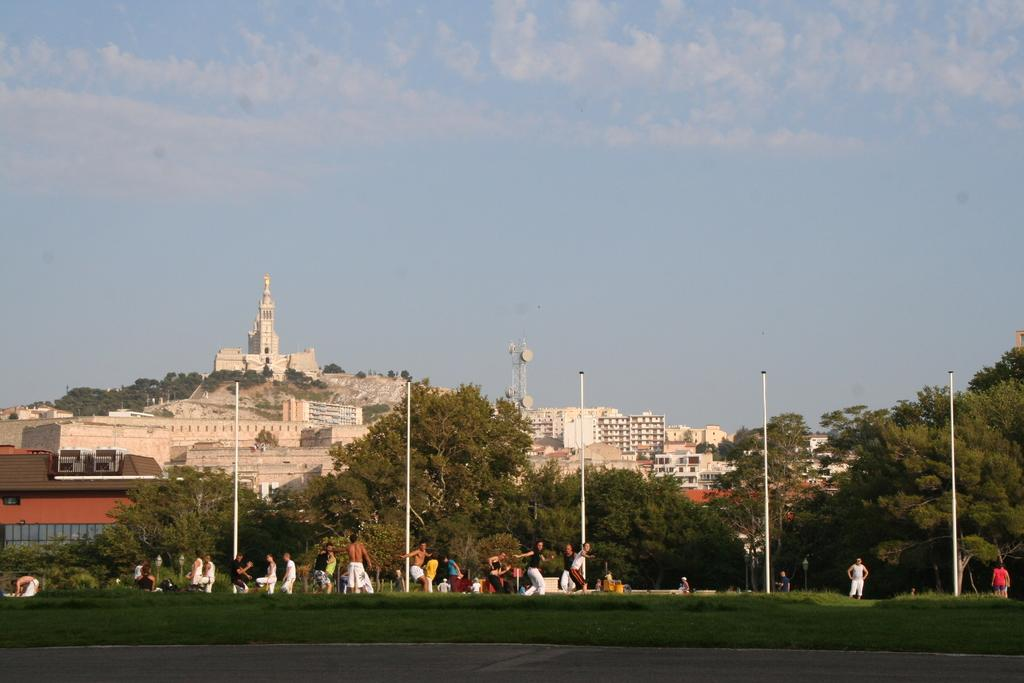How many people are in the image? There is a group of people in the image. Where are the people located in the image? The people are on the grass. What can be seen in the background of the image? There are poles, trees, buildings, and a tower in the background of the image. What is visible in the sky in the image? Clouds are visible in the background of the image. What type of cast is being worn by the person in the image? There is no person wearing a cast in the image. What discovery was made by the group of people in the image? There is no mention of a discovery in the image. 